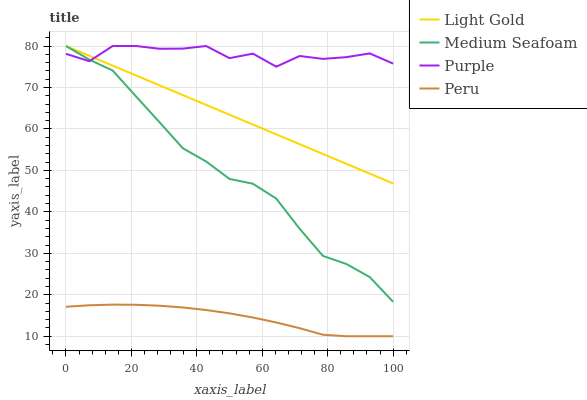Does Peru have the minimum area under the curve?
Answer yes or no. Yes. Does Purple have the maximum area under the curve?
Answer yes or no. Yes. Does Light Gold have the minimum area under the curve?
Answer yes or no. No. Does Light Gold have the maximum area under the curve?
Answer yes or no. No. Is Light Gold the smoothest?
Answer yes or no. Yes. Is Purple the roughest?
Answer yes or no. Yes. Is Medium Seafoam the smoothest?
Answer yes or no. No. Is Medium Seafoam the roughest?
Answer yes or no. No. Does Peru have the lowest value?
Answer yes or no. Yes. Does Light Gold have the lowest value?
Answer yes or no. No. Does Medium Seafoam have the highest value?
Answer yes or no. Yes. Does Peru have the highest value?
Answer yes or no. No. Is Peru less than Light Gold?
Answer yes or no. Yes. Is Purple greater than Peru?
Answer yes or no. Yes. Does Light Gold intersect Medium Seafoam?
Answer yes or no. Yes. Is Light Gold less than Medium Seafoam?
Answer yes or no. No. Is Light Gold greater than Medium Seafoam?
Answer yes or no. No. Does Peru intersect Light Gold?
Answer yes or no. No. 